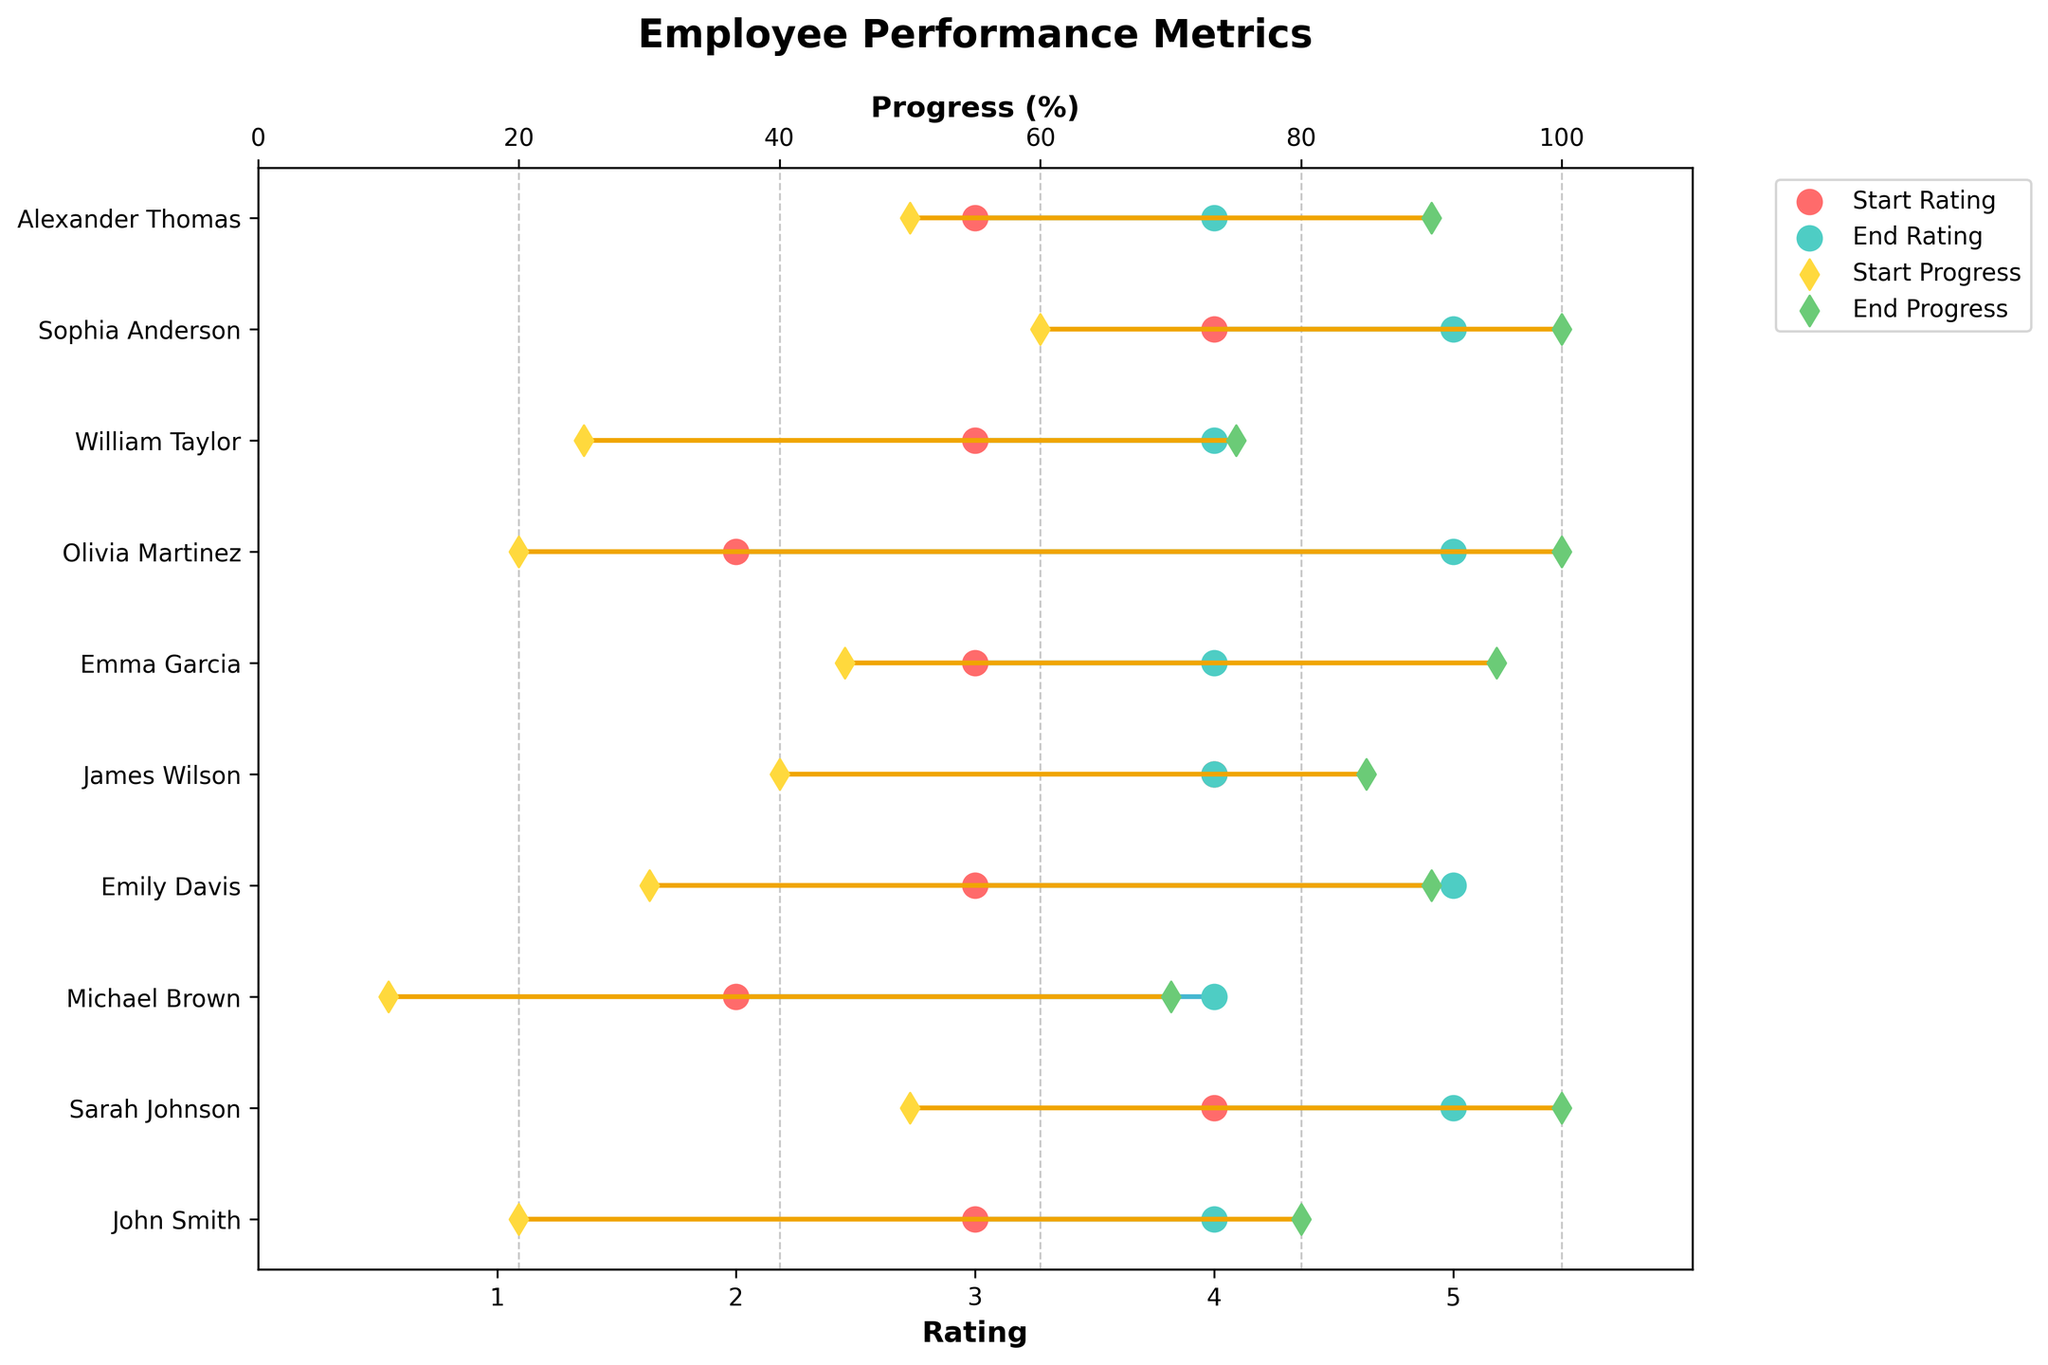What's the title of the plot? The title of the plot is located at the top center of the figure. It provides an overview of what the visual represents.
Answer: Employee Performance Metrics How many employees are displayed in the plot? The plot has the names of employees listed along the y-axis. Counting these names gives us the number of employees displayed.
Answer: 10 Which employee had the highest initial progress percentage? To find the employee with the highest initial progress, look at the starting progress values. Sarah Johnson has a starting progress of 50%, which is the highest among all employees.
Answer: Sarah Johnson What was John Smith's starting and ending ratings? John Smith's ratings are shown as red and green dots along the x-axis corresponding to his name. His starting rating is 3, and his ending rating is 4.
Answer: 3 and 4 Which task showed the greatest improvement in progress percentage? To find the task with the greatest improvement, subtract the start progress from the end progress for each task and look for the highest value. Olivia Martinez's Deployment task improved from 20% to 100%, yielding an 80% increase.
Answer: Deployment Describe the change in Emily Davis's performance from start to end. Emily Davis's performance can be understood by looking at her starting and ending rating and progress points. She started with a rating of 3 and a progress of 30%, ending with a rating of 5 and a progress of 90%. This indicates a significant improvement in both metrics.
Answer: Significant improvement in both rating and progress Which employee had no change in their rating from start to end? Both the start and end ratings need to be examined for each employee. James Wilson maintained a start and end rating of 4.
Answer: James Wilson What's the average start rating across all employees? Sum all the start ratings and divide by the number of employees: (3 + 4 + 2 + 3 + 4 + 3 + 2 + 3 + 4 + 3) / 10 = 31 / 10 = 3.1
Answer: 3.1 How did Michael Brown's progress change over the course of the project? Finding Michael Brown, his start progress was 10%, and his end progress was 70%, representing a 60% increase.
Answer: 60% increase Which task ended with the highest rating? The task with the highest ending rating is checked by comparing all the end ratings. Sarah Johnson, Emily Davis, Olivia Martinez, and Sophia Anderson all ended with a rating of 5, the highest. But without comparing across tasks explicitly, consider each "Task" contributed equally to the final outcome.
Answer: Several ended with a rating of 5 